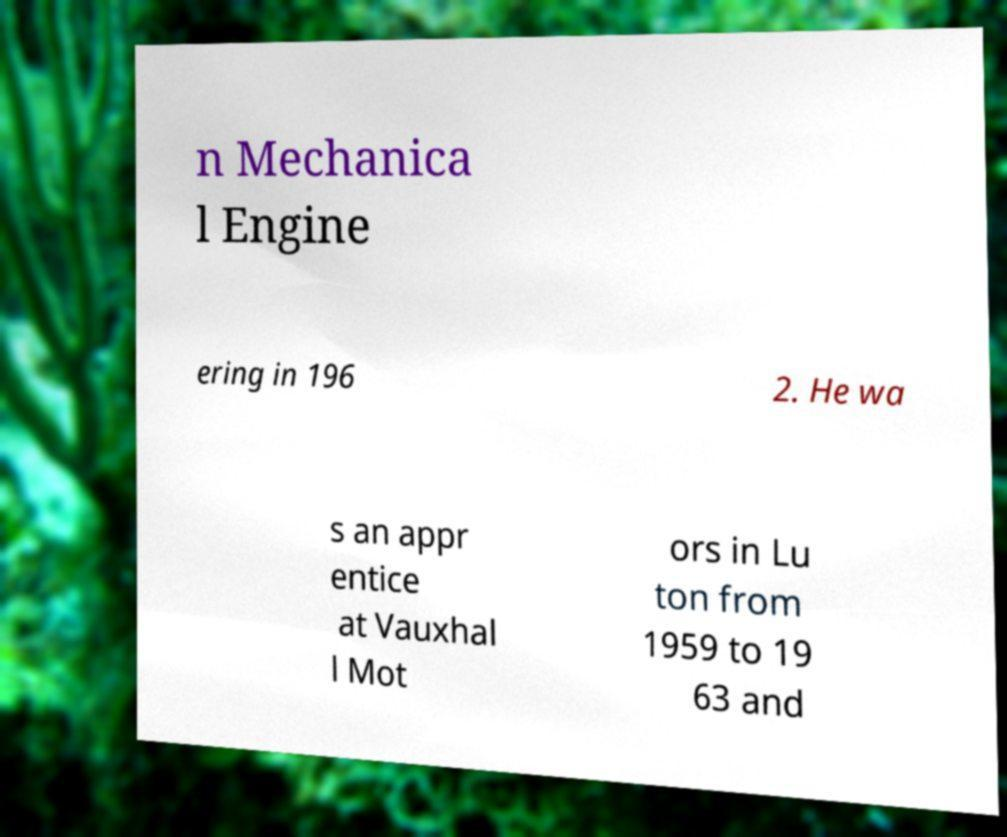Could you extract and type out the text from this image? n Mechanica l Engine ering in 196 2. He wa s an appr entice at Vauxhal l Mot ors in Lu ton from 1959 to 19 63 and 